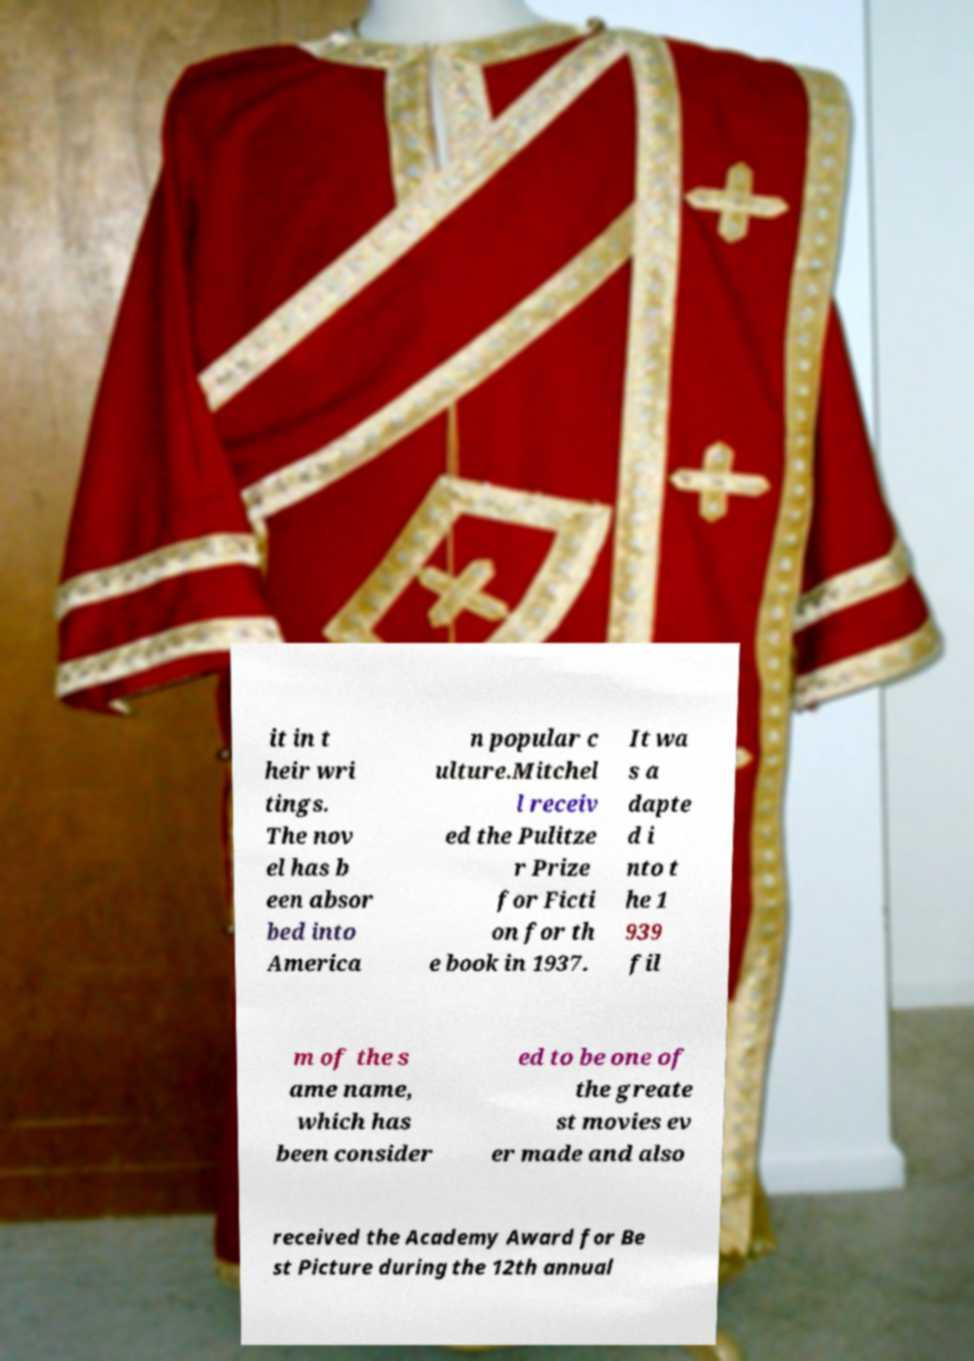What messages or text are displayed in this image? I need them in a readable, typed format. it in t heir wri tings. The nov el has b een absor bed into America n popular c ulture.Mitchel l receiv ed the Pulitze r Prize for Ficti on for th e book in 1937. It wa s a dapte d i nto t he 1 939 fil m of the s ame name, which has been consider ed to be one of the greate st movies ev er made and also received the Academy Award for Be st Picture during the 12th annual 